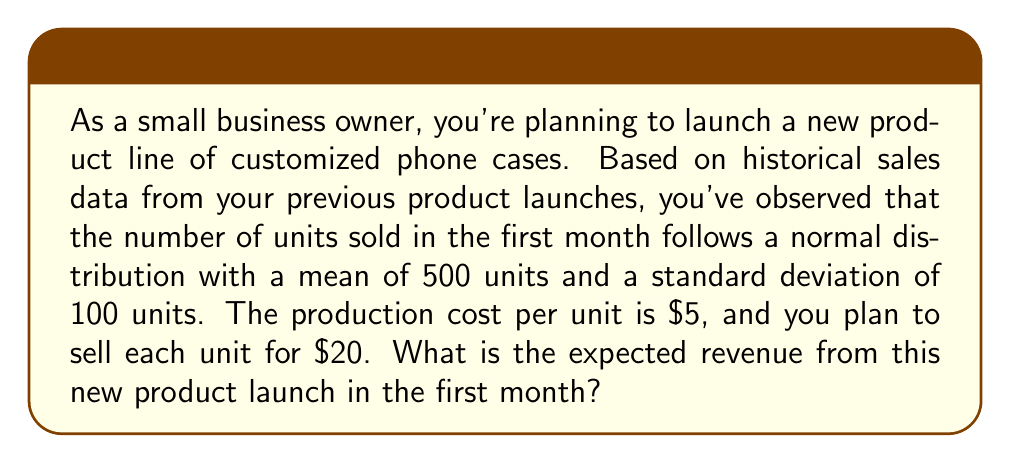Could you help me with this problem? Let's approach this step-by-step:

1. Define the random variable:
   Let X be the number of units sold in the first month.

2. Given information:
   - X follows a normal distribution: $X \sim N(\mu, \sigma)$
   - Mean (μ) = 500 units
   - Standard deviation (σ) = 100 units
   - Cost per unit = $5
   - Selling price per unit = $20

3. Calculate the expected number of units sold:
   Since X follows a normal distribution, the expected value of X is equal to its mean.
   $E(X) = \mu = 500$ units

4. Calculate the revenue per unit:
   Revenue per unit = Selling price - Cost
   $20 - $5 = $15 per unit

5. Calculate the expected revenue:
   Expected Revenue = Expected number of units sold × Revenue per unit
   $E(\text{Revenue}) = E(X) \times $15$
   $E(\text{Revenue}) = 500 \times $15 = $7,500$

Therefore, the expected revenue from the new product launch in the first month is $7,500.
Answer: $7,500 